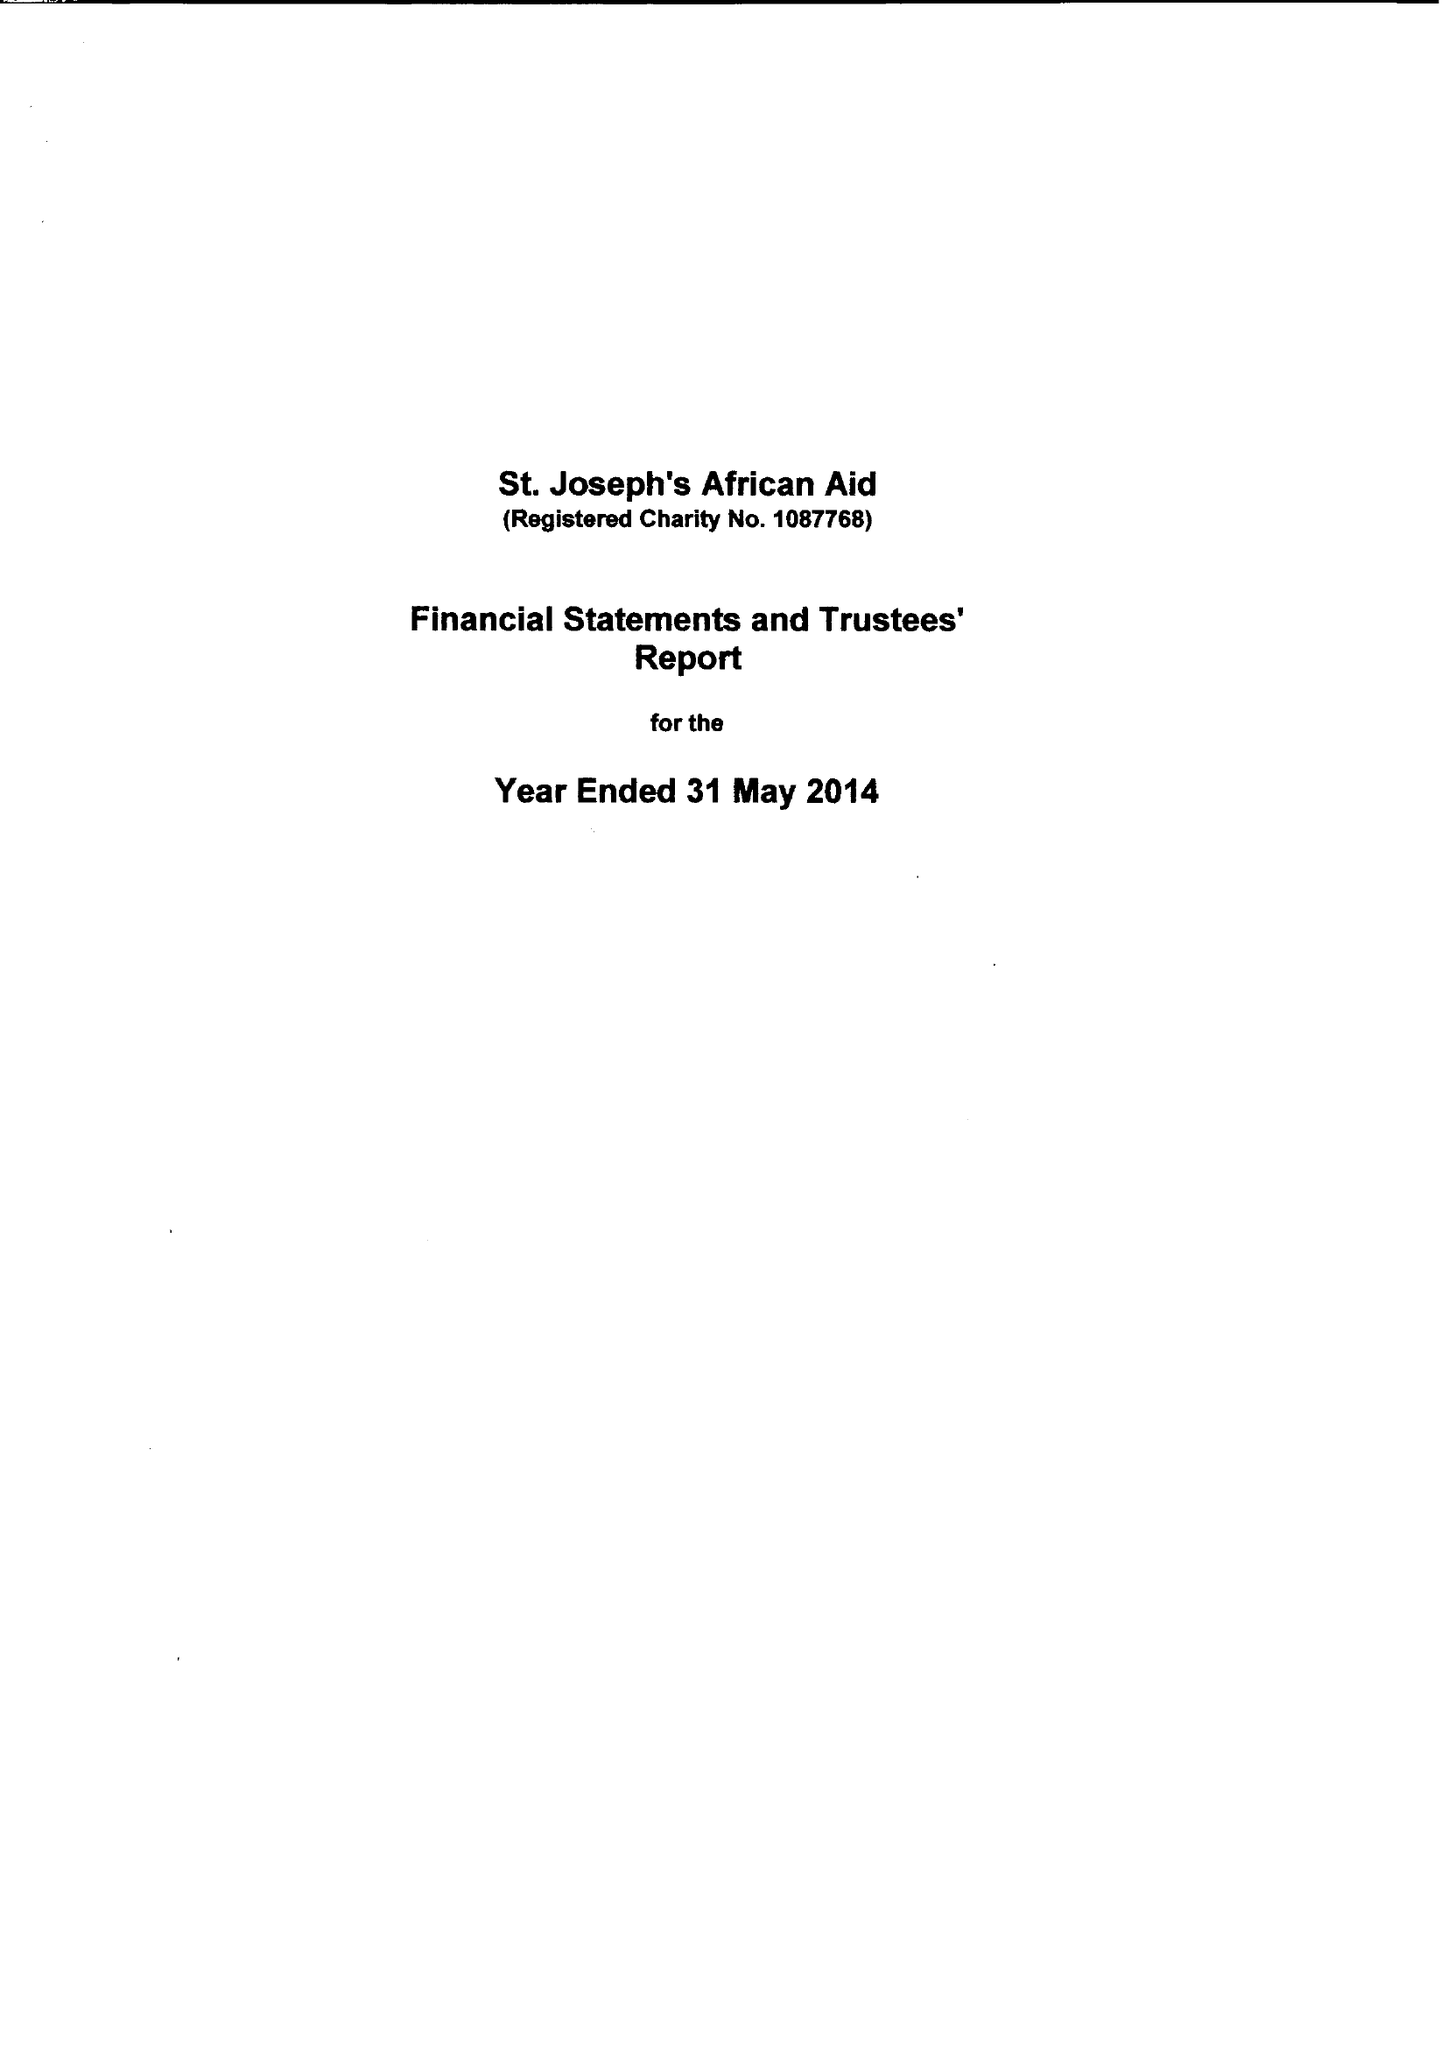What is the value for the report_date?
Answer the question using a single word or phrase. 2014-05-31 